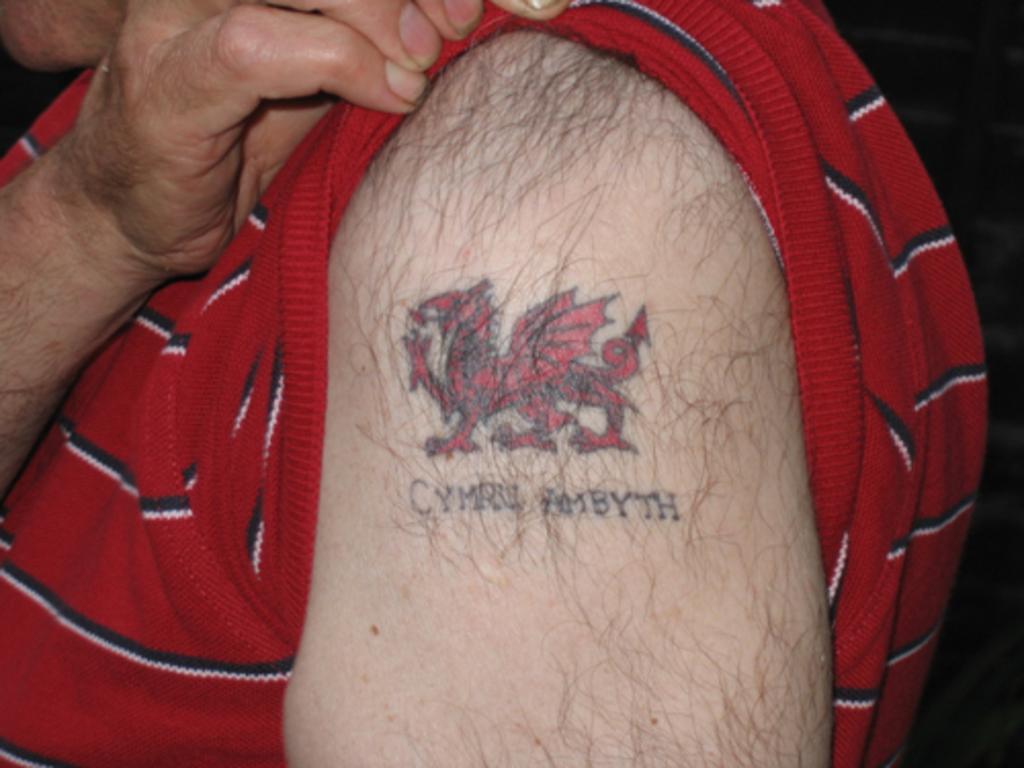Can you describe this image briefly? In this image, we can see a person wearing a red t-shirt. Here we can see a tattoo and some text on the person's arm. 